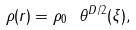Convert formula to latex. <formula><loc_0><loc_0><loc_500><loc_500>\rho ( r ) = \rho _ { 0 } \ \theta ^ { D / 2 } ( \xi ) ,</formula> 